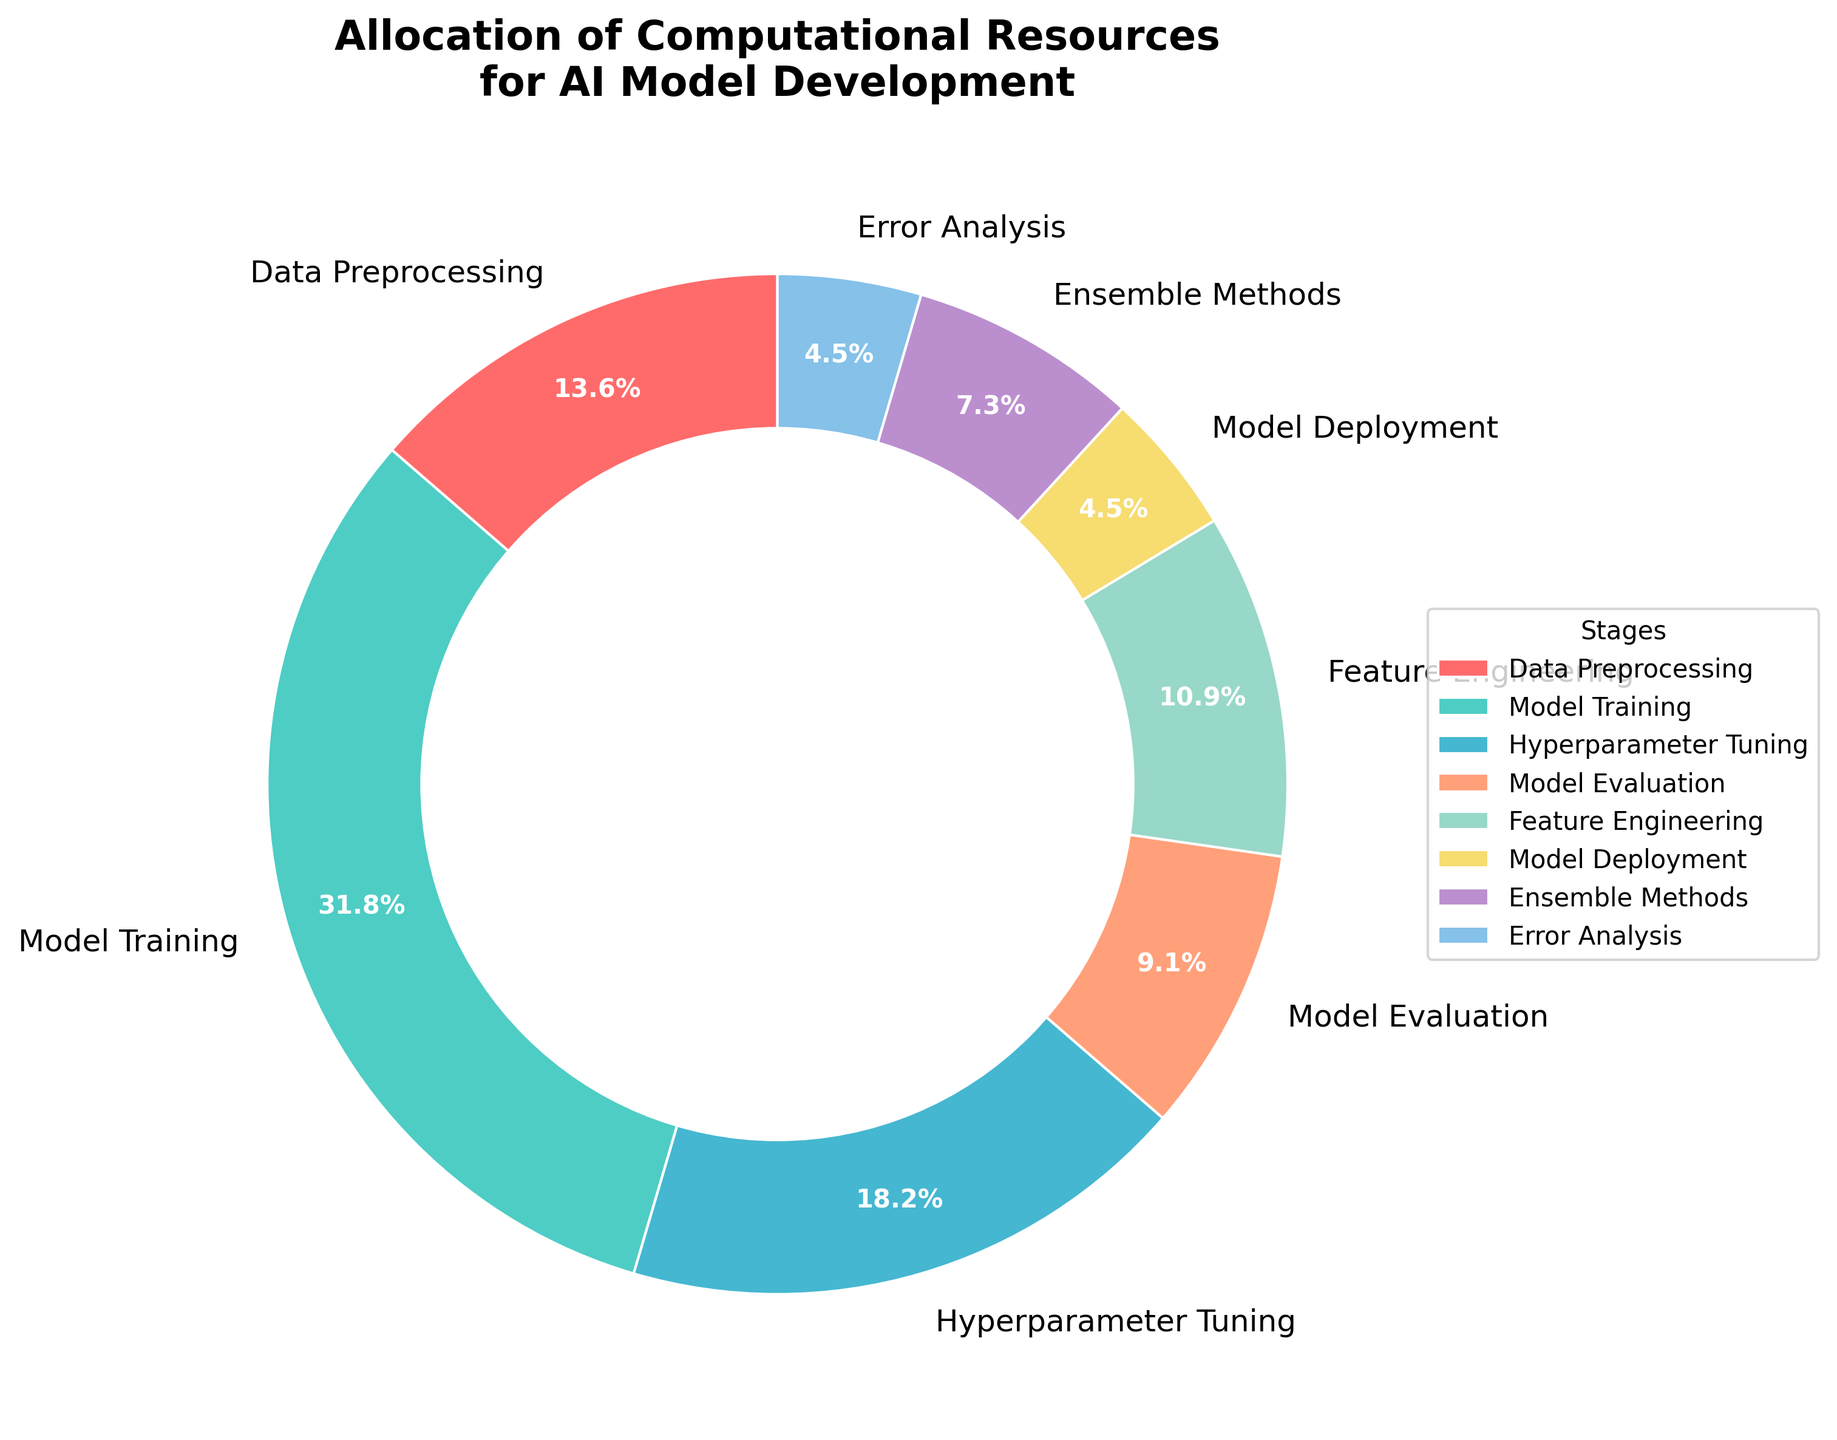Which stage uses the highest percentage of computational resources? The pie chart shows that the "Model Training" section has the largest wedge, indicating the highest percentage of computational resources.
Answer: Model Training How much more computational resources does Hyperparameter Tuning use compared to Model Deployment? The pie chart shows Hyperparameter Tuning at 20% and Model Deployment at 5%. The difference is 20% - 5% = 15%.
Answer: 15% What is the combined percentage of computational resources allocated to Data Preprocessing and Feature Engineering? The pie chart shows Data Preprocessing at 15% and Feature Engineering at 12%. The combined percentage is 15% + 12% = 27%.
Answer: 27% Which stage uses fewer computational resources: Error Analysis or Model Evaluation? The pie chart shows Error Analysis at 5% and Model Evaluation at 10%. Error Analysis uses fewer computational resources.
Answer: Error Analysis Are the computational resources for Ensemble Methods greater than, less than, or equal to those for Error Analysis? The pie chart shows Ensemble Methods at 8% and Error Analysis at 5%. The computational resources for Ensemble Methods are greater.
Answer: Greater How many stages use less than 10% of computational resources? The pie chart has wedges labeled with their percentages. The stages less than 10% are Model Evaluation, Model Deployment, Ensemble Methods, and Error Analysis (4 stages).
Answer: 4 What is the percentage difference between the computation resources used for Model Training and Hyperparameter Tuning? The pie chart shows Model Training at 35% and Hyperparameter Tuning at 20%. The difference is 35% - 20% = 15%.
Answer: 15% How much percentage of computational resources is allocated to stages other than Model Training? The pie chart shows the total percentage as 100%. Subtracting the Model Training's portion, 100% - 35% = 65%.
Answer: 65% What percentage of computational resources is allocated to Model Deployment and Error Analysis combined? The pie chart shows Model Deployment at 5% and Error Analysis at 5%. Combined, they use 5% + 5% = 10%.
Answer: 10% Which two stages have the smallest allocation of computational resources? The pie chart shows that Model Deployment and Error Analysis both have the smallest wedges at 5%.
Answer: Model Deployment and Error Analysis 